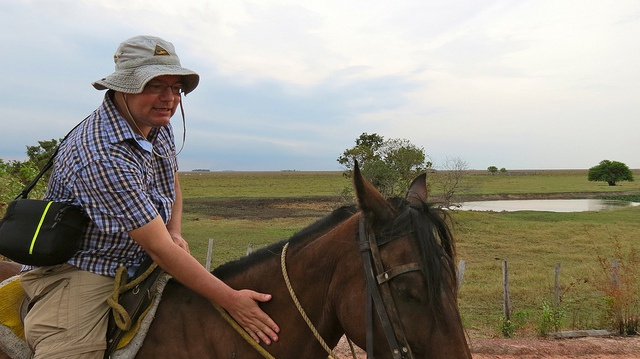Describe the objects in this image and their specific colors. I can see people in lightgray, black, gray, and maroon tones, horse in lightgray, black, maroon, and gray tones, and handbag in lightgray, black, darkgreen, gray, and yellow tones in this image. 